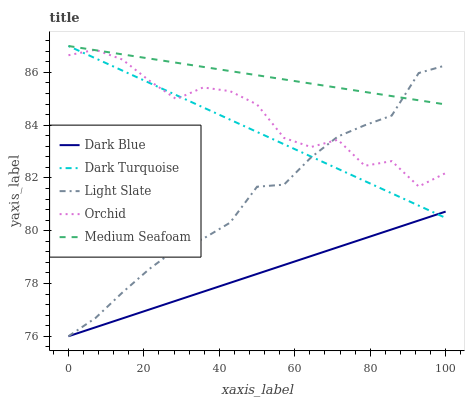Does Dark Blue have the minimum area under the curve?
Answer yes or no. Yes. Does Medium Seafoam have the maximum area under the curve?
Answer yes or no. Yes. Does Orchid have the minimum area under the curve?
Answer yes or no. No. Does Orchid have the maximum area under the curve?
Answer yes or no. No. Is Dark Turquoise the smoothest?
Answer yes or no. Yes. Is Orchid the roughest?
Answer yes or no. Yes. Is Dark Blue the smoothest?
Answer yes or no. No. Is Dark Blue the roughest?
Answer yes or no. No. Does Light Slate have the lowest value?
Answer yes or no. Yes. Does Orchid have the lowest value?
Answer yes or no. No. Does Dark Turquoise have the highest value?
Answer yes or no. Yes. Does Orchid have the highest value?
Answer yes or no. No. Is Dark Blue less than Orchid?
Answer yes or no. Yes. Is Orchid greater than Dark Blue?
Answer yes or no. Yes. Does Light Slate intersect Orchid?
Answer yes or no. Yes. Is Light Slate less than Orchid?
Answer yes or no. No. Is Light Slate greater than Orchid?
Answer yes or no. No. Does Dark Blue intersect Orchid?
Answer yes or no. No. 